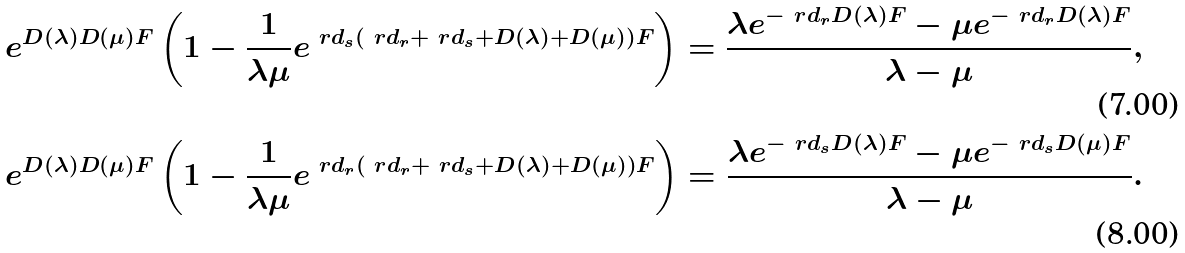Convert formula to latex. <formula><loc_0><loc_0><loc_500><loc_500>e ^ { D ( \lambda ) D ( \mu ) F } \left ( 1 - \frac { 1 } { \lambda \mu } e ^ { \ r d _ { s } ( \ r d _ { r } + \ r d _ { s } + D ( \lambda ) + D ( \mu ) ) F } \right ) = \frac { \lambda e ^ { - \ r d _ { r } D ( \lambda ) F } - \mu e ^ { - \ r d _ { r } D ( \lambda ) F } } { \lambda - \mu } , \\ e ^ { D ( \lambda ) D ( \mu ) F } \left ( 1 - \frac { 1 } { \lambda \mu } e ^ { \ r d _ { r } ( \ r d _ { r } + \ r d _ { s } + D ( \lambda ) + D ( \mu ) ) F } \right ) = \frac { \lambda e ^ { - \ r d _ { s } D ( \lambda ) F } - \mu e ^ { - \ r d _ { s } D ( \mu ) F } } { \lambda - \mu } .</formula> 